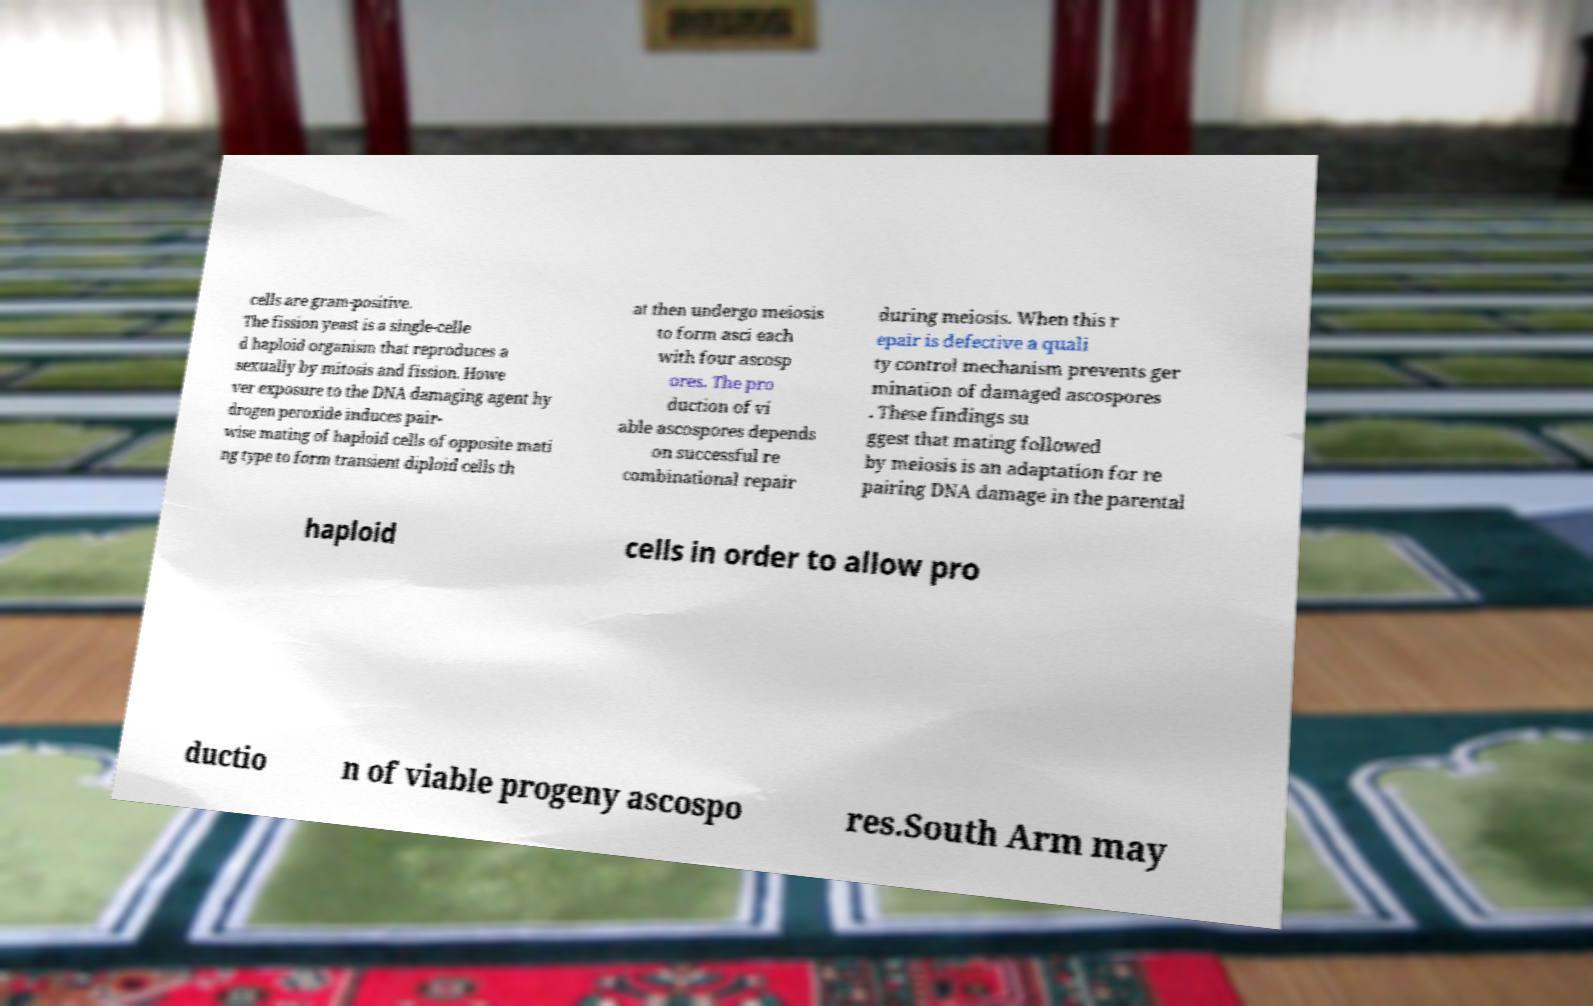What messages or text are displayed in this image? I need them in a readable, typed format. cells are gram-positive. The fission yeast is a single-celle d haploid organism that reproduces a sexually by mitosis and fission. Howe ver exposure to the DNA damaging agent hy drogen peroxide induces pair- wise mating of haploid cells of opposite mati ng type to form transient diploid cells th at then undergo meiosis to form asci each with four ascosp ores. The pro duction of vi able ascospores depends on successful re combinational repair during meiosis. When this r epair is defective a quali ty control mechanism prevents ger mination of damaged ascospores . These findings su ggest that mating followed by meiosis is an adaptation for re pairing DNA damage in the parental haploid cells in order to allow pro ductio n of viable progeny ascospo res.South Arm may 